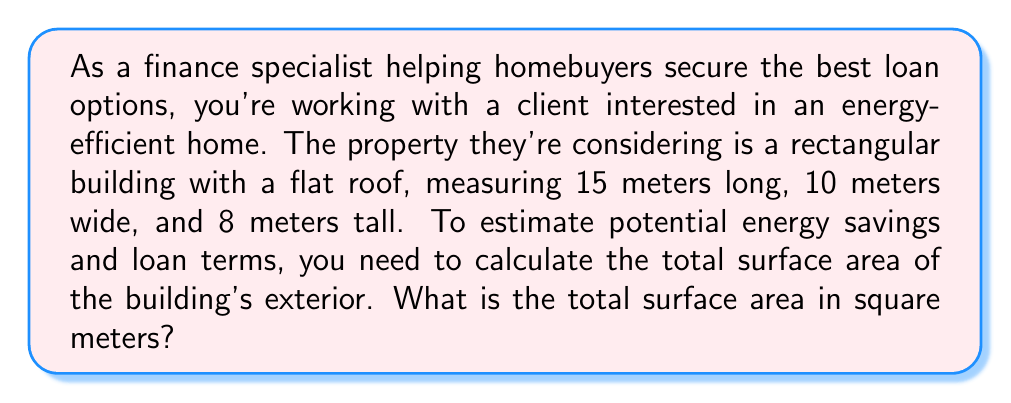Could you help me with this problem? To solve this problem, we need to calculate the surface area of all sides of the building, including the roof. Let's break it down step-by-step:

1. Identify the dimensions:
   Length (l) = 15 m
   Width (w) = 10 m
   Height (h) = 8 m

2. Calculate the area of each surface:
   
   a) Roof (top) and foundation (bottom):
      $$A_{roof} = A_{foundation} = l \times w = 15 \text{ m} \times 10 \text{ m} = 150 \text{ m}^2$$
   
   b) Front and back walls:
      $$A_{front} = A_{back} = l \times h = 15 \text{ m} \times 8 \text{ m} = 120 \text{ m}^2$$
   
   c) Side walls:
      $$A_{side} = w \times h = 10 \text{ m} \times 8 \text{ m} = 80 \text{ m}^2$$

3. Sum up all the surface areas:
   $$\begin{align*}
   \text{Total Surface Area} &= A_{roof} + A_{foundation} + 2A_{front} + 2A_{side} \\
   &= 150 + 150 + 2(120) + 2(80) \\
   &= 300 + 240 + 160 \\
   &= 700 \text{ m}^2
   \end{align*}$$

This calculation provides the total exterior surface area of the building, which is crucial for estimating energy efficiency and potential savings on heating and cooling costs. This information can be used to assess the long-term financial benefits of the property and help determine appropriate loan terms.
Answer: The total surface area of the building is 700 square meters. 